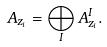Convert formula to latex. <formula><loc_0><loc_0><loc_500><loc_500>A _ { z _ { i } } = \bigoplus _ { I } A ^ { I } _ { z _ { i } } .</formula> 